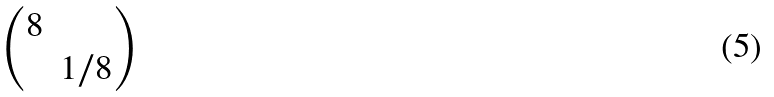<formula> <loc_0><loc_0><loc_500><loc_500>\begin{pmatrix} 8 & \\ & 1 / 8 \end{pmatrix}</formula> 